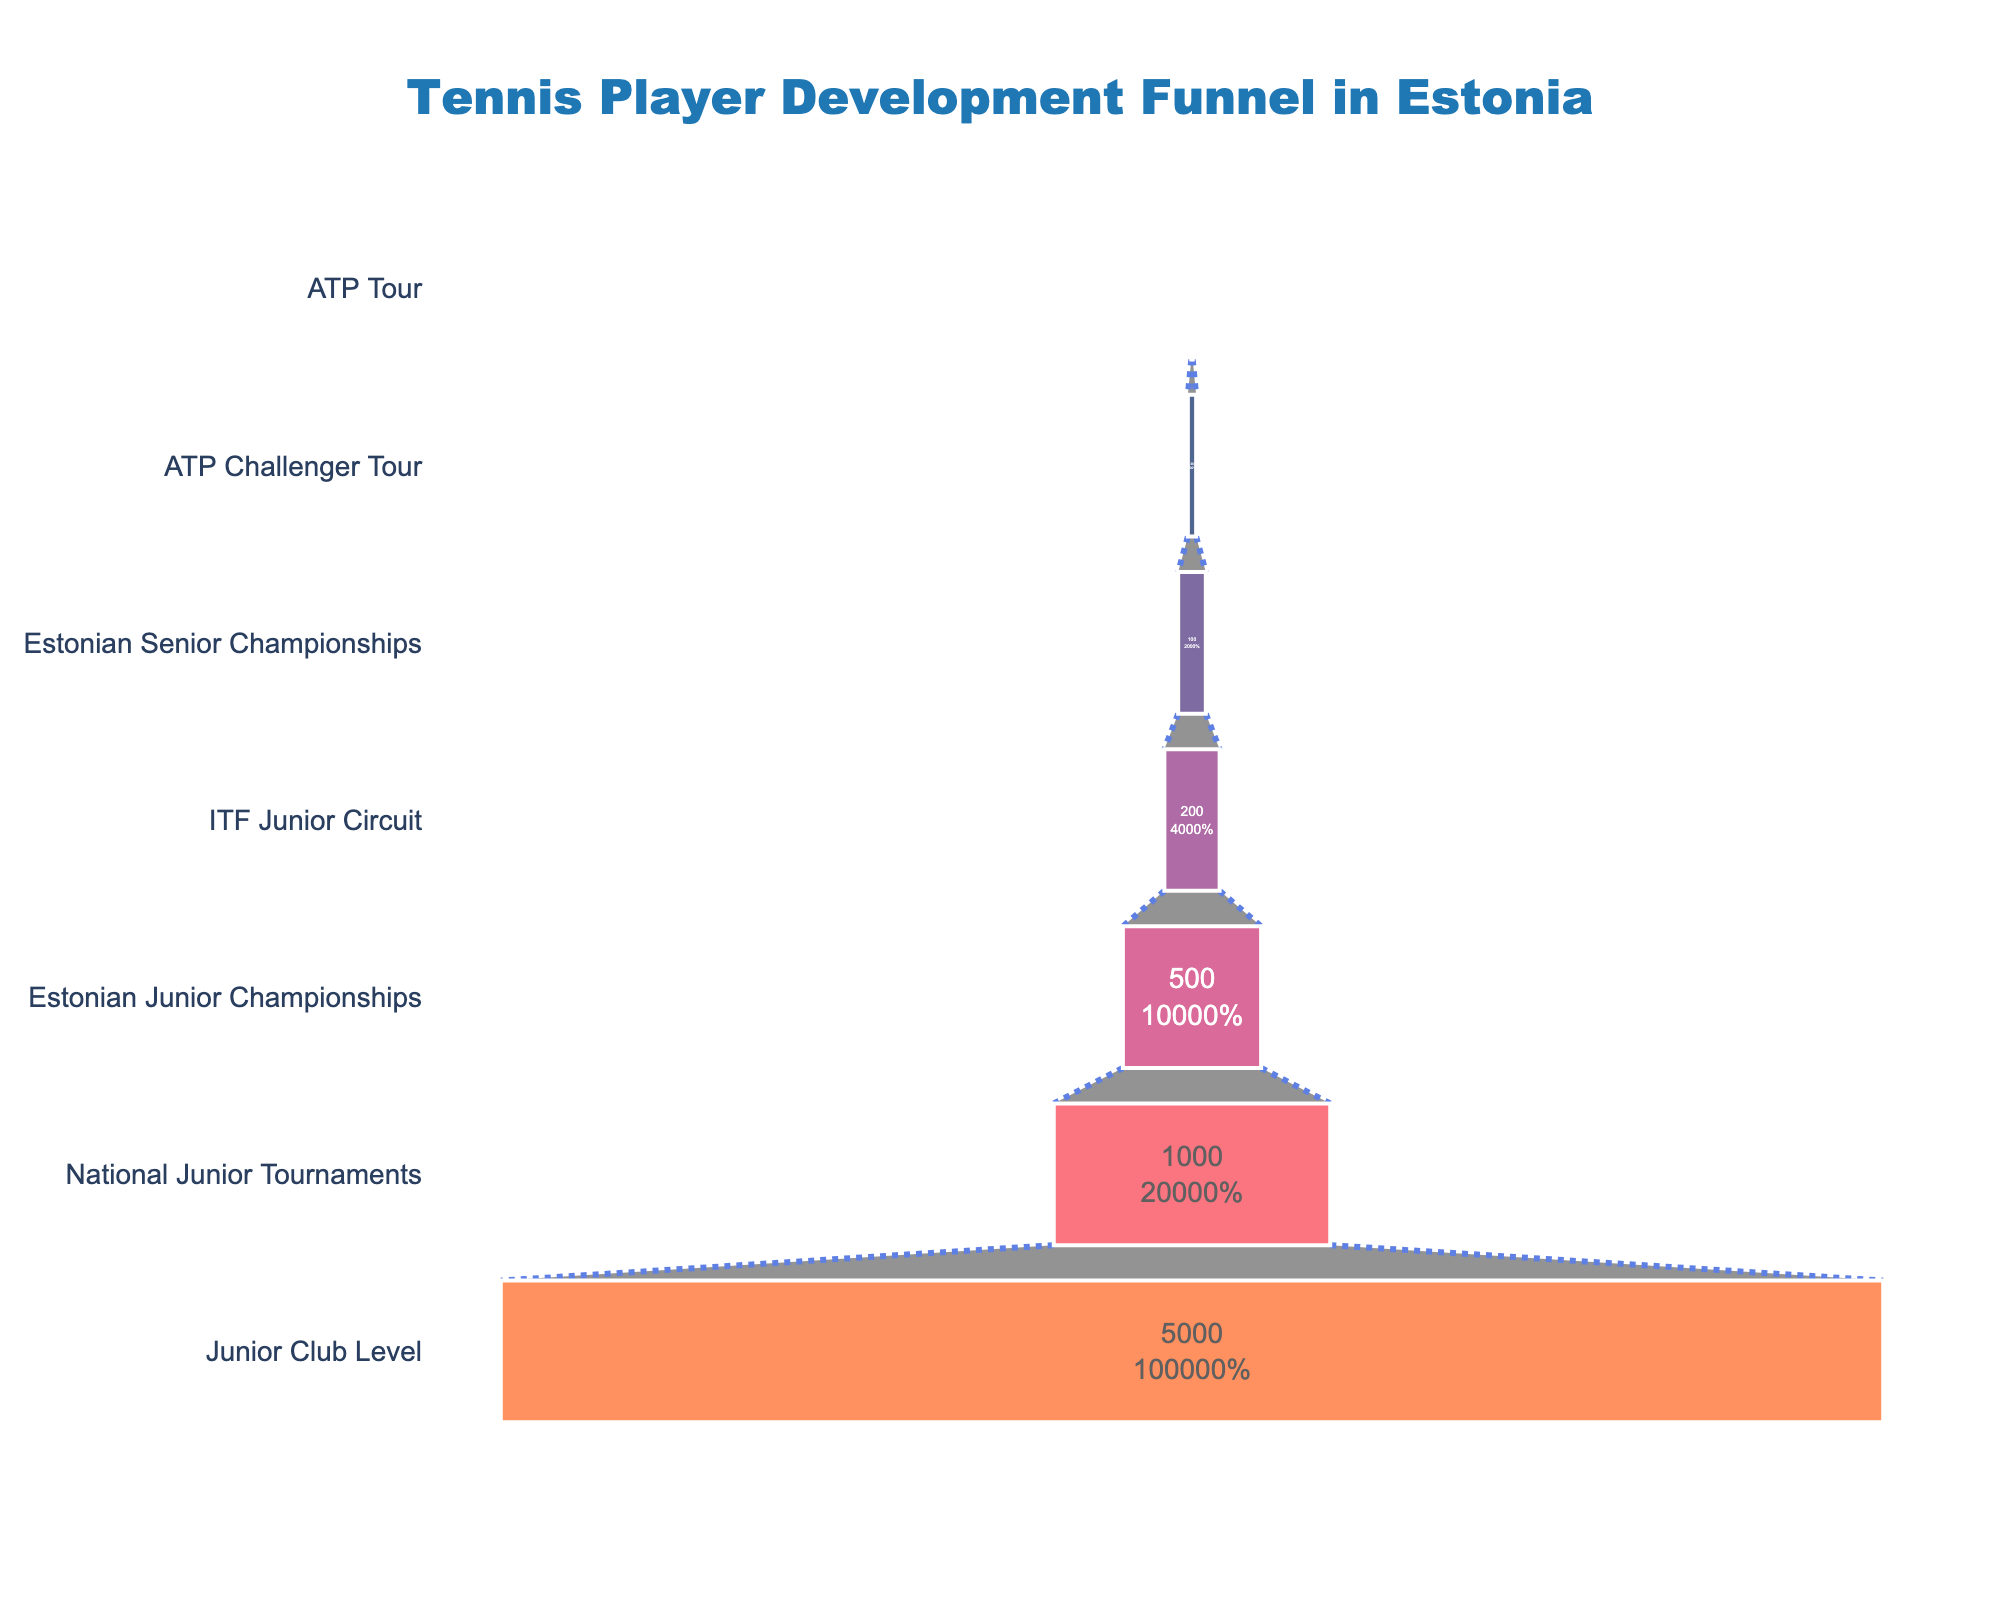What is the title of the funnel chart? The title is written prominently at the top of the funnel chart. It reads "Tennis Player Development Funnel in Estonia".
Answer: Tennis Player Development Funnel in Estonia How many stages are represented in this funnel chart? By counting the unique stages listed on the y-axis of the funnel chart, we can identify that there are seven stages represented.
Answer: Seven What is the percentage of players who advance from ITF Junior Circuit to Estonian Senior Championships? The ITF Junior Circuit has 200 players, and the Estonian Senior Championships has 100 players. The percentage is calculated as (100/200)*100%.
Answer: 50% Compare the number of players at the Junior Club Level to those at the ATP Tour level. The Junior Club Level has 5000 players, whereas the ATP Tour level has 5 players. The difference is 5000 - 5.
Answer: 4995 What stage has the second highest number of players? Looking at the funnel chart, the second highest number of players is at the National Junior Tournaments stage, with 1000 players.
Answer: National Junior Tournaments What is the attrition rate from National Junior Tournaments to Estonian Junior Championships? National Junior Tournaments has 1000 players and Estonian Junior Championships has 500 players. The attrition rate is (1000 - 500) / 1000 = 0.5 or 50%.
Answer: 50% What stage represents 1% of the initial number of players at the Junior Club Level? The Junior Club Level starts with 5000 players. 1% of 5000 is 50. The stage that has closest to 50 players is Estonian Senior Championships with 100 players.
Answer: Estonian Senior Championships Which stage has a color closest to orange? By observing the colors of each stage in the funnel chart, the ATP Challenger Tour stage has a color close to orange.
Answer: ATP Challenger Tour What is the difference in the number of players between the ATP Challenger Tour and the ATP Tour stages? The ATP Challenger Tour has 30 players, and the ATP Tour has 5 players. The difference is 30 - 5.
Answer: 25 Which stage has the greatest drop in player numbers compared to its previous stage? Comparing the player numbers between consecutive stages: 5000 to 1000 (4000 drop), 1000 to 500 (500 drop), 500 to 200 (300 drop), 200 to 100 (100 drop), 100 to 30 (70 drop), and 30 to 5 (25 drop). The greatest drop is from Junior Club Level to National Junior Tournaments.
Answer: From Junior Club Level to National Junior Tournaments 